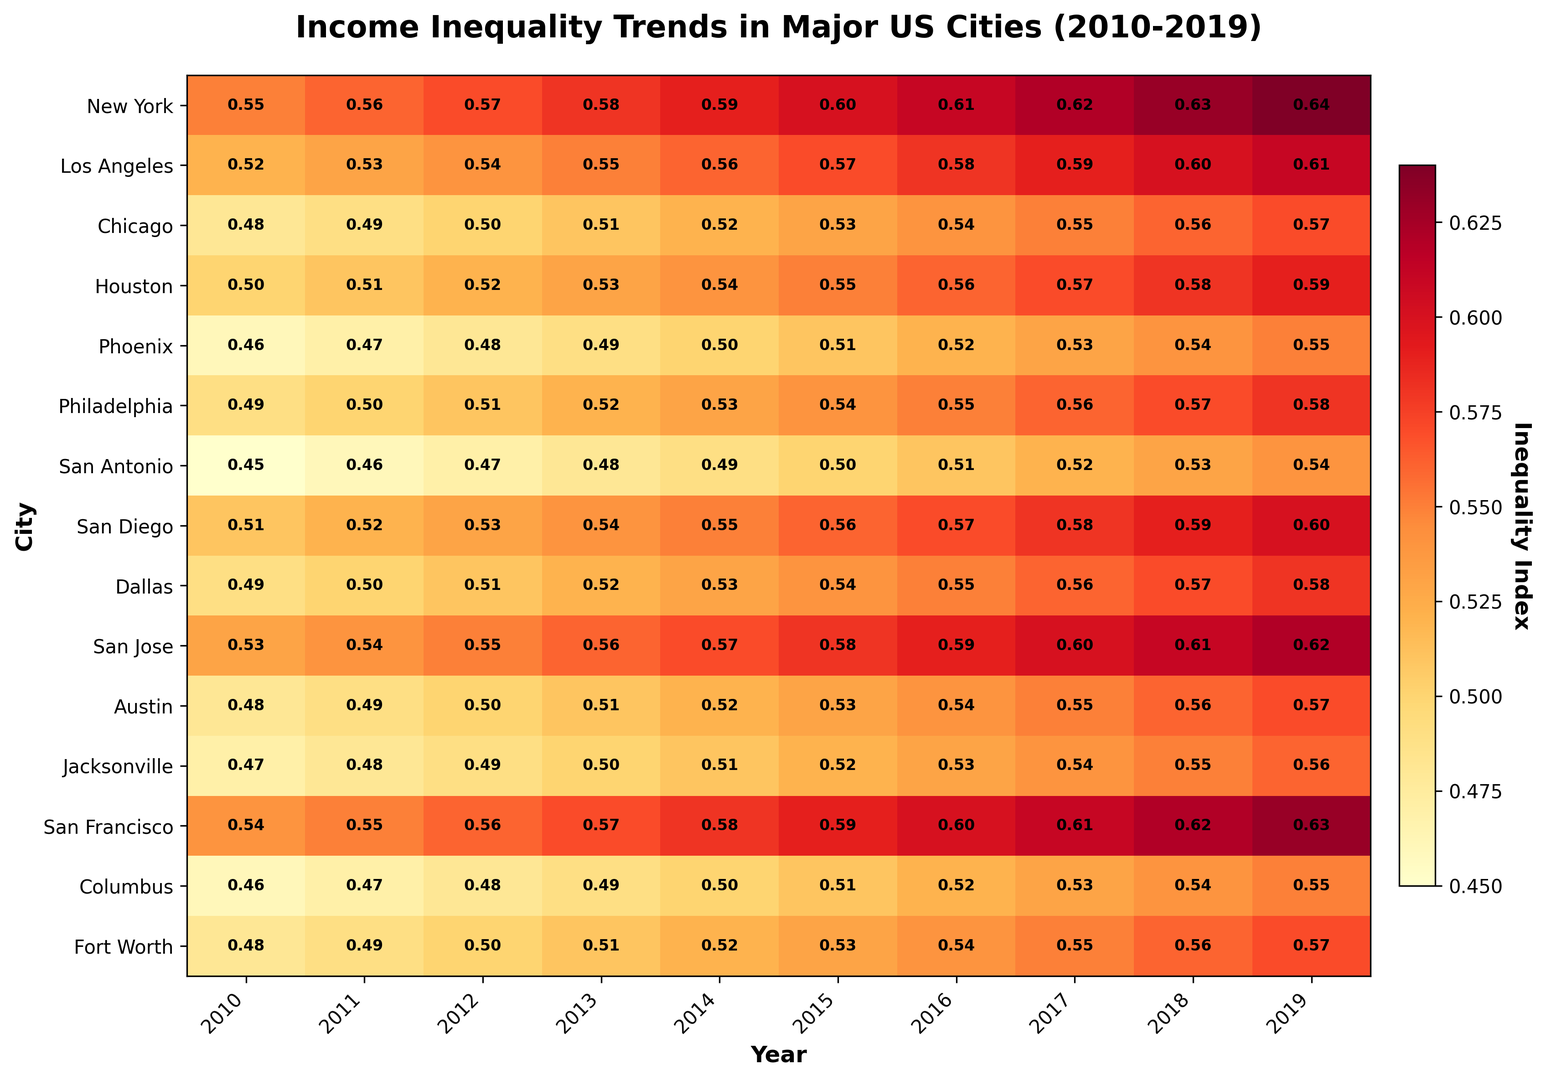What city had the highest income inequality index in 2019? Look at the 2019 column and identify the city with the darkest red cell, which signifies the highest value. New York has a value of 0.64, which is the highest for that year.
Answer: New York Which city experienced the largest increase in income inequality index from 2010 to 2019? Calculate the difference between the indices for 2010 and 2019 for each city and find the city with the largest difference. New York increased from 0.55 to 0.64, an increase of 0.09, which is the largest.
Answer: New York In which year did Los Angeles first surpass a 0.55 income inequality index? Look at the data for Los Angeles from 2010 to 2019. The value first exceeded 0.55 in 2014.
Answer: 2014 What is the average income inequality index for San Francisco from 2010 to 2019? Sum the values for San Francisco from 2010 to 2019 and divide by the number of years. (0.54 + 0.55 + 0.56 + 0.57 + 0.58 + 0.59 + 0.60 + 0.61 + 0.62 + 0.63) / 10 = 5.85 / 10 = 0.585.
Answer: 0.585 Which city had the lowest income inequality index in 2015? Review the 2015 column and identify the city with the brightest yellow cell, which signifies the lowest value. San Antonio had a value of 0.50 in 2015, the lowest for that year.
Answer: San Antonio Did any city have a decreasing trend in income inequality index at any point from 2010 to 2019? Review the trends for each city. All cities have either steady or increasing trends in income inequality index, with no periods of decrease.
Answer: No Which year had the most significant increase in income inequality index for Houston? Examine the year-to-year differences for Houston. The largest increase occurred between 2010 and 2011, with a difference of 0.01.
Answer: 2011 What is the overall trend of income inequality index for Phoenix from 2010 to 2019? Observe the values for Phoenix over the years. The index increases steadily from 0.46 in 2010 to 0.55 in 2019.
Answer: Increasing Compare the income inequality index between Chicago and Austin in 2019. Which city had a higher index? Look at the 2019 values for both cities. Chicago had a value of 0.57, while Austin had a value of 0.57. Both cities had the same index in 2019.
Answer: Equal 